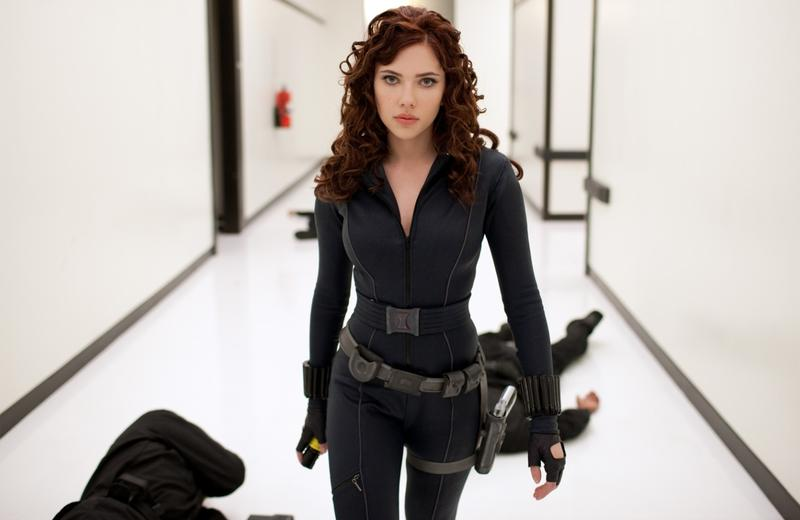Analyze the image in a comprehensive and detailed manner. The image captures a moment featuring the actress Scarlett Johansson, known for her role as Natasha Romanoff, or Black Widow, in the Marvel Cinematic Universe. She stands in a stark white hallway, its walls and floor traced with black lines that add a sense of depth and perspective to the scene. Dressed in her signature black jumpsuit, complete with a gray belt and holsters for her weapons, she embodies the strength and determination of her character. Her hair, styled in loose curls, adds a touch of softness to her otherwise formidable appearance. A serious expression is etched on her face as she gazes off to the side, suggesting a moment of intense focus or contemplation. In the background, two individuals lie on the ground, hinting at a recent confrontation and underscoring the prowess of Black Widow. 